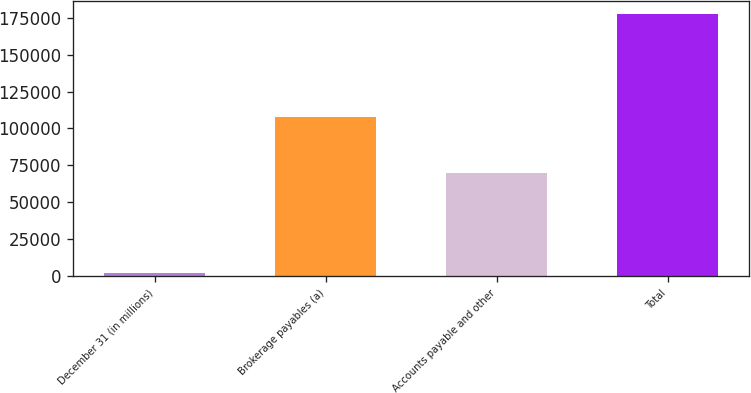Convert chart. <chart><loc_0><loc_0><loc_500><loc_500><bar_chart><fcel>December 31 (in millions)<fcel>Brokerage payables (a)<fcel>Accounts payable and other<fcel>Total<nl><fcel>2015<fcel>107632<fcel>70006<fcel>177638<nl></chart> 